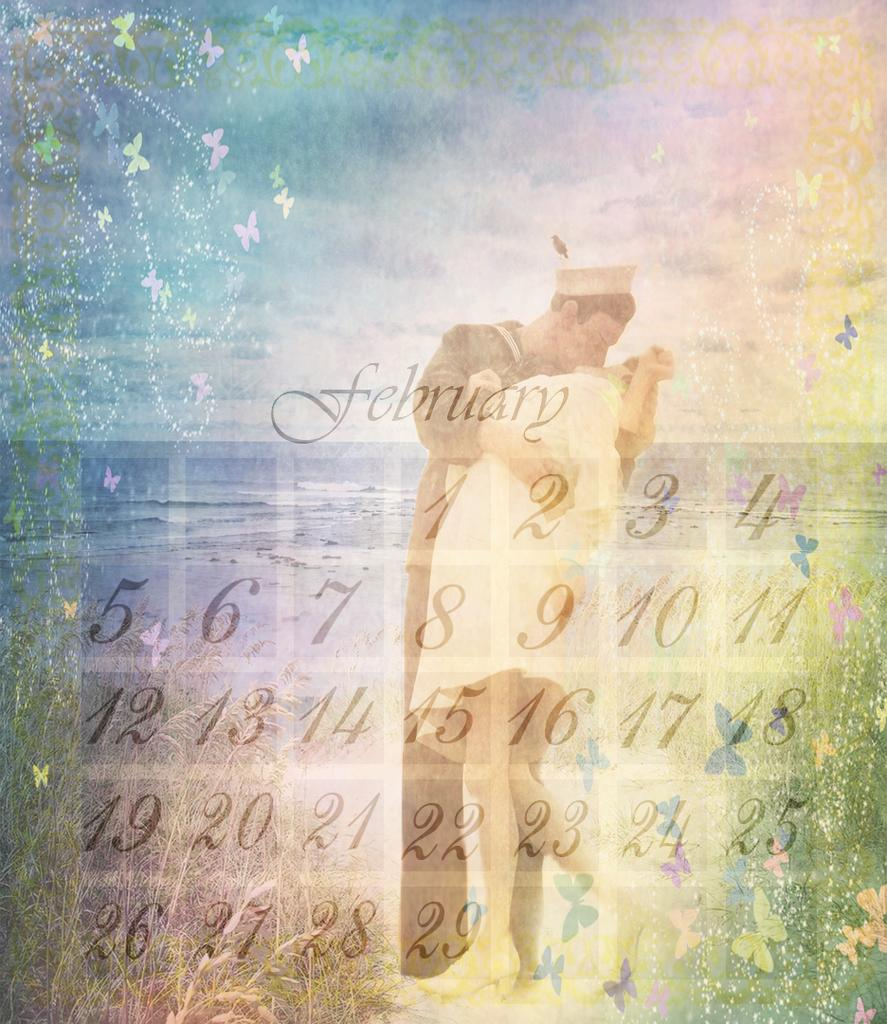What type of editing has been done to the image? The image is edited, but the specific type of editing is not mentioned in the facts. What can be found in the image besides the man and woman? There is text, numbers, butterflies, sky, and water visible in the image. What are the man and woman doing in the image? The man and woman are kissing each other in the image. What is the background of the image? The background of the image includes sky and water. What type of holiday is being celebrated in the image? There is no indication of a holiday being celebrated in the image. What type of doll is sitting on the man's shoulder in the image? There is no doll present in the image. 